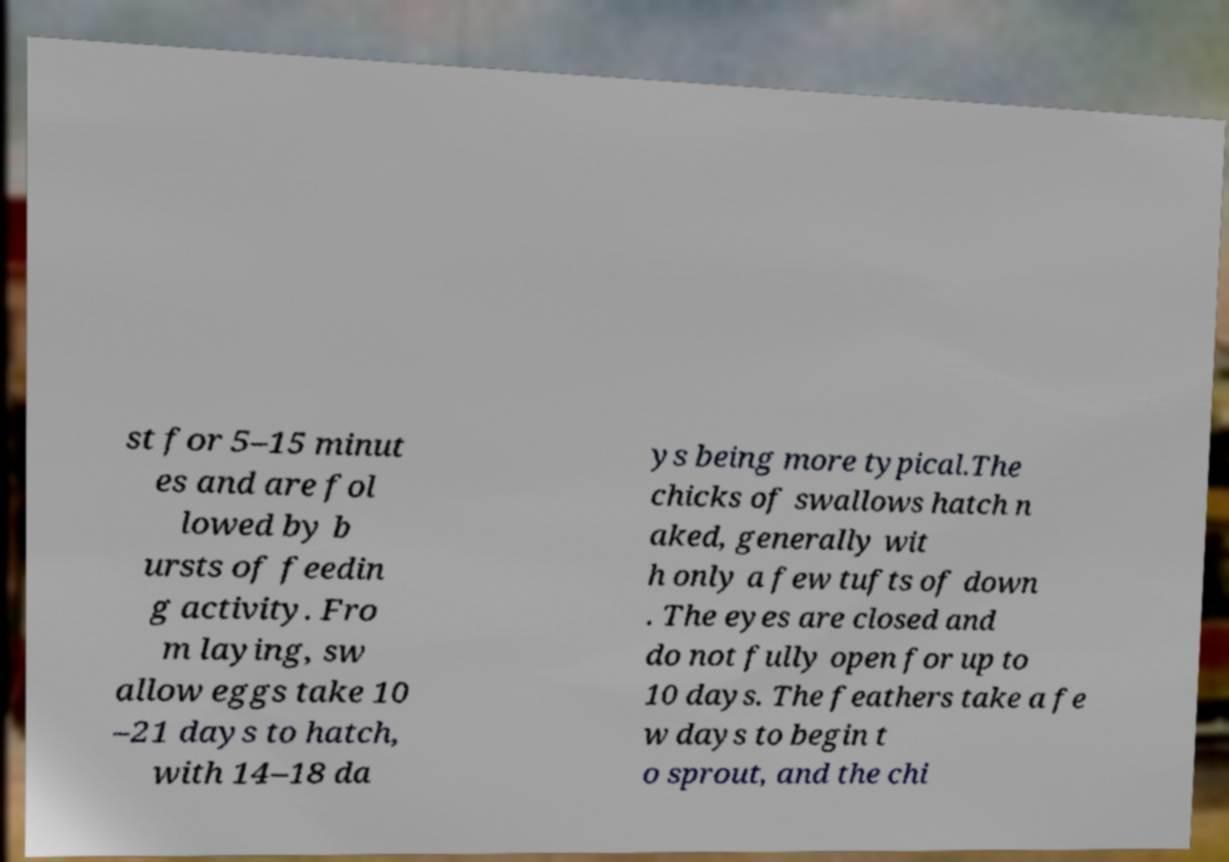Could you assist in decoding the text presented in this image and type it out clearly? st for 5–15 minut es and are fol lowed by b ursts of feedin g activity. Fro m laying, sw allow eggs take 10 –21 days to hatch, with 14–18 da ys being more typical.The chicks of swallows hatch n aked, generally wit h only a few tufts of down . The eyes are closed and do not fully open for up to 10 days. The feathers take a fe w days to begin t o sprout, and the chi 